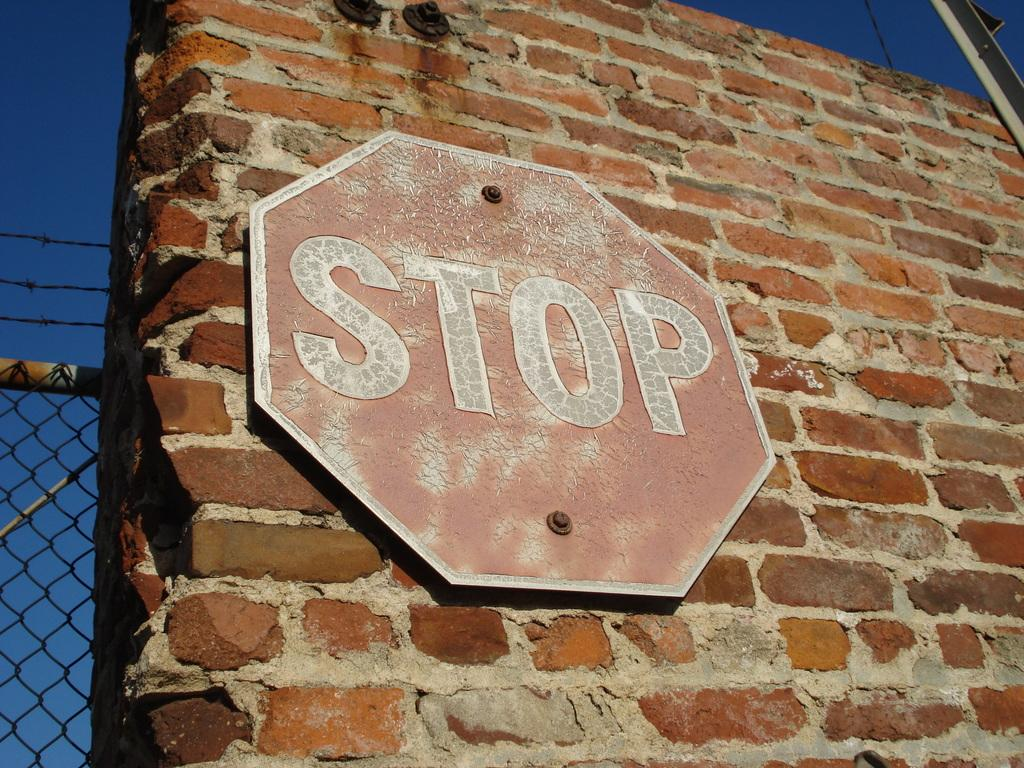<image>
Describe the image concisely. red stop sign mounted on a brick wall 